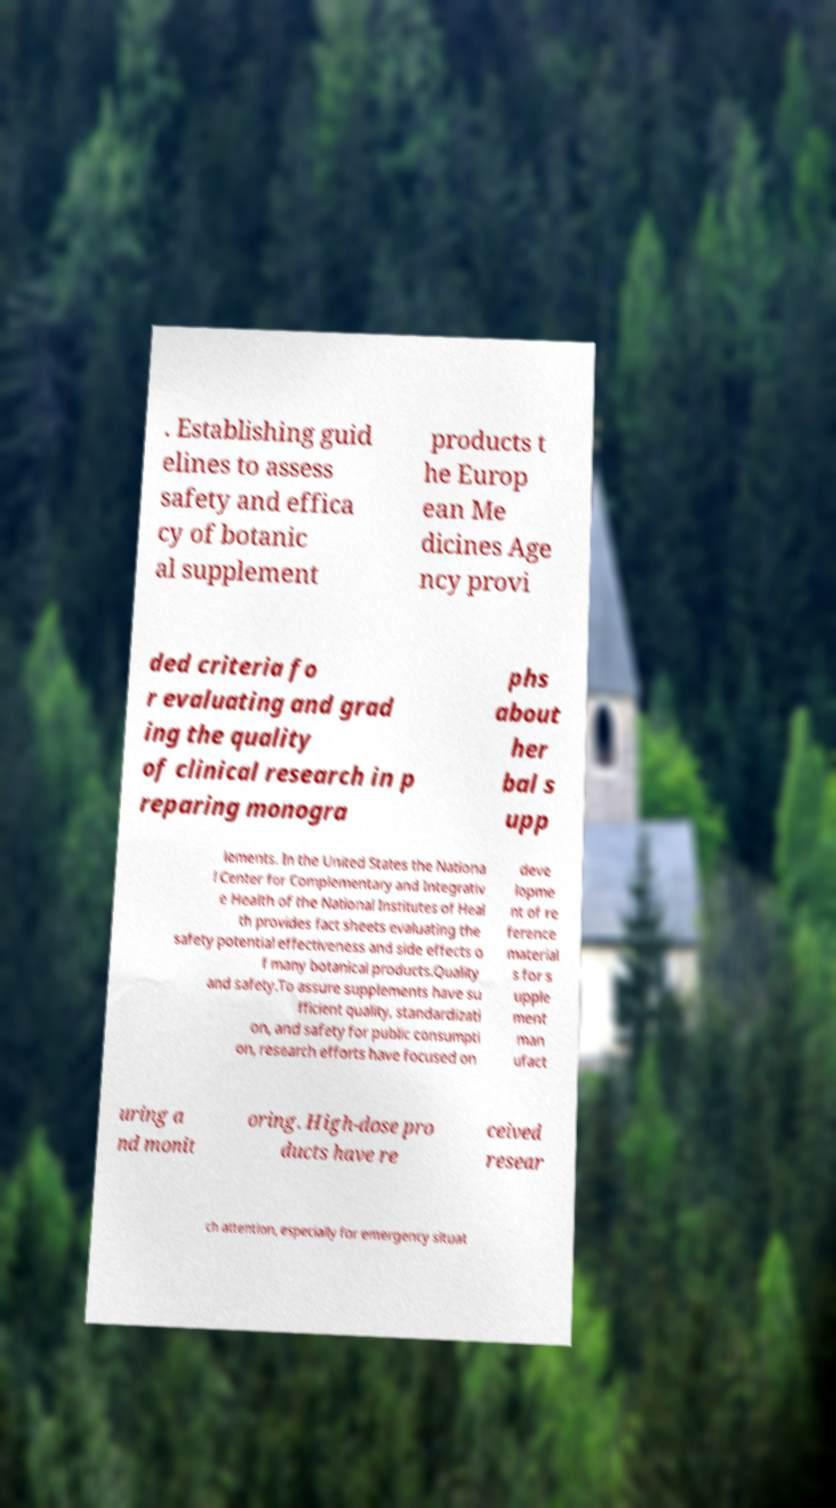Could you assist in decoding the text presented in this image and type it out clearly? . Establishing guid elines to assess safety and effica cy of botanic al supplement products t he Europ ean Me dicines Age ncy provi ded criteria fo r evaluating and grad ing the quality of clinical research in p reparing monogra phs about her bal s upp lements. In the United States the Nationa l Center for Complementary and Integrativ e Health of the National Institutes of Heal th provides fact sheets evaluating the safety potential effectiveness and side effects o f many botanical products.Quality and safety.To assure supplements have su fficient quality, standardizati on, and safety for public consumpti on, research efforts have focused on deve lopme nt of re ference material s for s upple ment man ufact uring a nd monit oring. High-dose pro ducts have re ceived resear ch attention, especially for emergency situat 